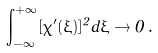Convert formula to latex. <formula><loc_0><loc_0><loc_500><loc_500>\int _ { - \infty } ^ { + \infty } [ \chi ^ { \prime } ( \xi ) ] ^ { 2 } d \xi \to 0 \, .</formula> 